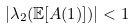<formula> <loc_0><loc_0><loc_500><loc_500>| \lambda _ { 2 } ( \mathbb { E } [ A ( 1 ) ] ) | < 1</formula> 